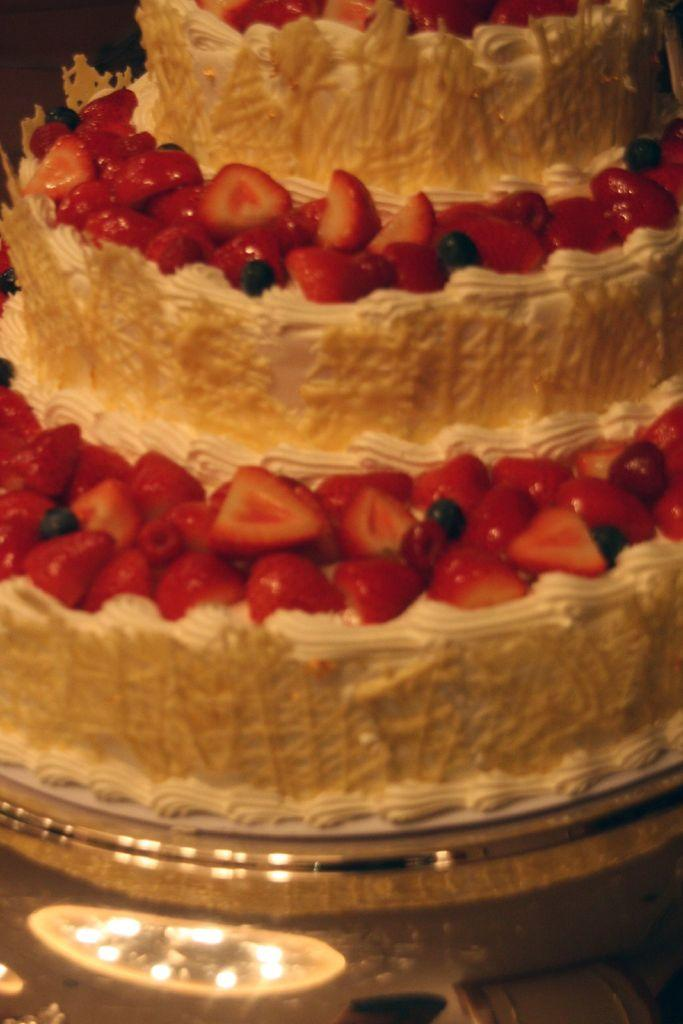What type of cake is shown in the image? There is a step cake in the image. What is the cake placed on? The cake is on an object, which is not specified in the facts. What decorations are on the cake? There are strawberry slices on the cake. What type of copper material is used to make the bomb in the image? There is no bomb or copper material present in the image; it features a step cake with strawberry slices. 